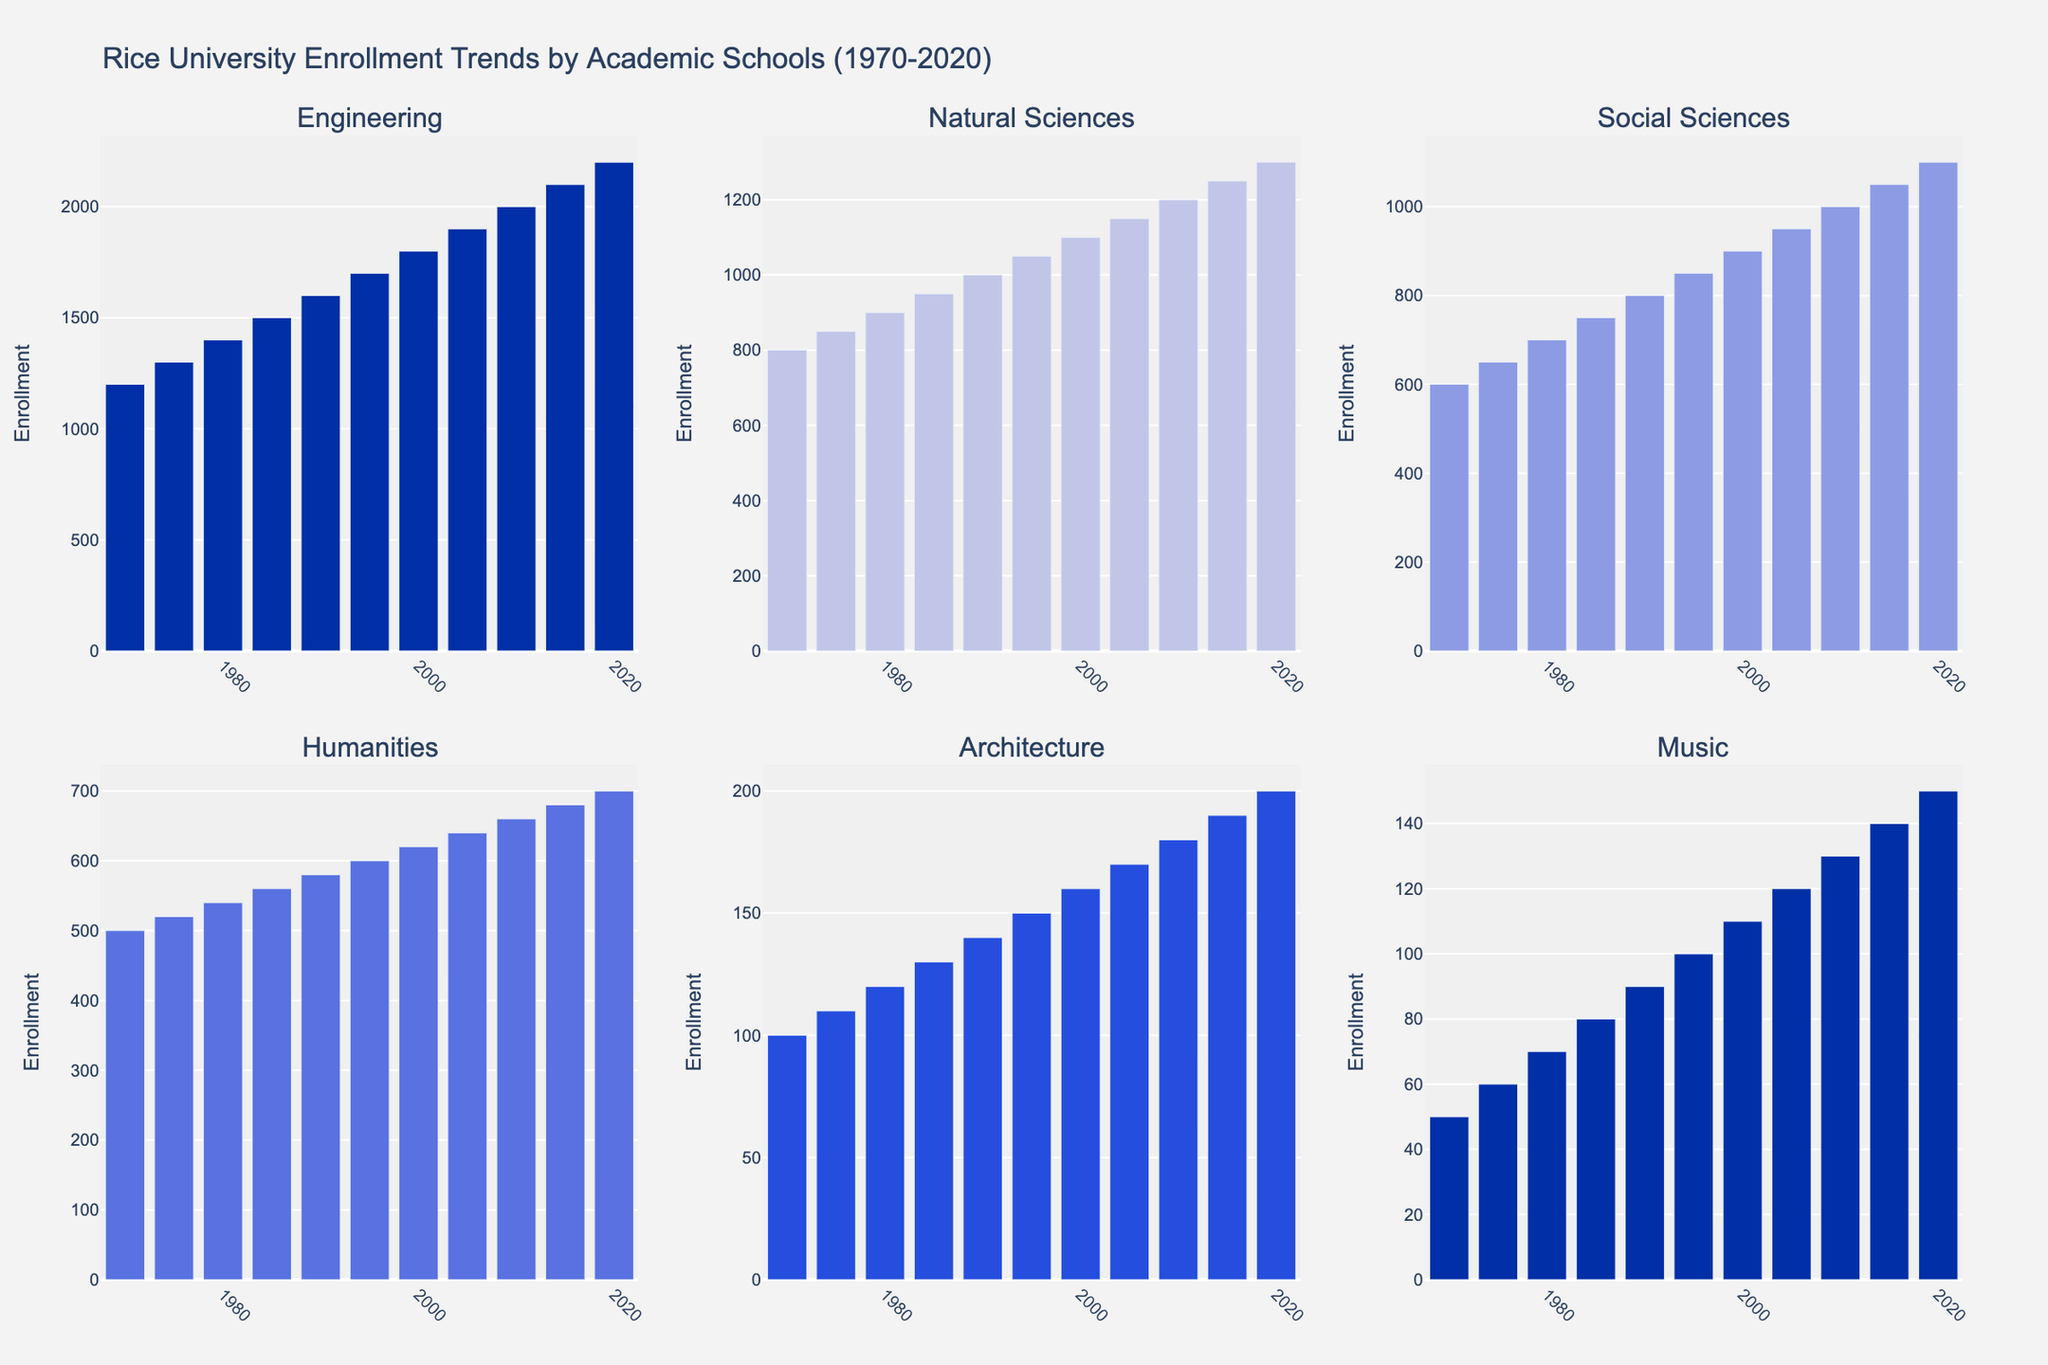What's the total student enrollment in 1970 combining all schools? To find the total student enrollment in 1970, we sum the enrollment numbers from all schools: Engineering (1200), Natural Sciences (800), Social Sciences (600), Humanities (500), Architecture (100), Music (50). Thus, 1200 + 800 + 600 + 500 + 100 + 50 = 3250
Answer: 3250 Which school had the highest enrollment in 2020? To determine which school had the highest enrollment in 2020, we compare the enrollment numbers for all schools: Engineering (2200), Natural Sciences (1300), Social Sciences (1100), Humanities (700), Architecture (200), Music (150). Engineering has the highest enrollment.
Answer: Engineering How did the increase in student enrollment in Engineering compare to Humanities from 1970 to 2020? Calculate the difference in enrollments for Engineering and Humanities from 1970 to 2020. Engineering increased from 1200 to 2200, a 1000 student increase. Humanities increased from 500 to 700, a 200 student increase. Thus, Engineering's enrollment increased by 1000, while Humanities increased by 200.
Answer: Engineering increased by 1000, Humanities by 200 Which school had the smallest enrollment increase between 1970 and 2020? To find the smallest increase, calculate the difference for each school between 1970 and 2020: Engineering (2200 - 1200 = 1000), Natural Sciences (1300 - 800 = 500), Social Sciences (1100 - 600 = 500), Humanities (700 - 500 = 200), Architecture (200 - 100 = 100), Music (150 - 50 = 100). Architecture and Music both had the smallest increase of 100.
Answer: Architecture and Music What is the average enrollment for the Social Sciences school over the five decades (1970-2020)? To find the average, sum the enrollments for each decade and divide by the number of data points (11): (600 + 650 + 700 + 750 + 800 + 850 + 900 + 950 + 1000 + 1050 + 1100) / 11 = 9300 / 11 = about 845.45
Answer: about 845.45 Between 1980 and 2010, which school had the greatest relative increase in student enrollment? Calculate the percentage increase for each school between 1980 and 2010. Engineering: ((2000-1400)/1400)*100 = 42.86%, Natural Sciences: ((1200-900)/900)*100 = 33.33%, Social Sciences: ((1000-700)/700)*100 = 42.86%, Humanities: ((660-540)/540)*100 = 22.22%, Architecture: ((180-120)/120)*100 = 50%, Music: ((130-70)/70)*100 = 85.71%. Music had the greatest relative increase.
Answer: Music What's the enrollment difference between Music and Architecture in 2015? Find the enrollment numbers for Music (140) and Architecture (190) in 2015, then subtract the smaller number from the larger one: 190 - 140 = 50.
Answer: 50 How did the enrollment in Natural Sciences change from 1995 to 2020? Calculate the difference in enrollment numbers for Natural Sciences between 1995 and 2020: 1300 - 1050 = 250.
Answer: Increased by 250 What trend is observed in the enrollment of the Architecture school over the 50-year period? The enrollment in Architecture shows a steady increase from 100 students in 1970 to 200 students in 2020, doubling over the 50 years.
Answer: Steady increase, doubled Which year shows the first instance where the student enrollment in Engineering reached or surpassed 2000? Check the enrollment numbers for Engineering each year. The first year where it reached 2000 was in 2010.
Answer: 2010 